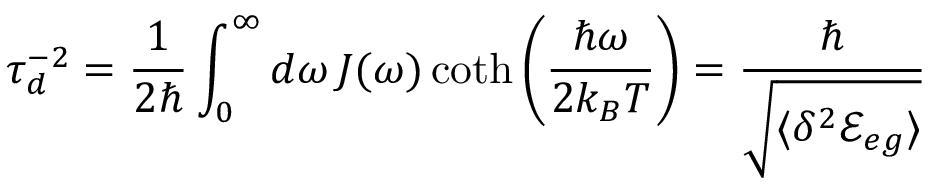<formula> <loc_0><loc_0><loc_500><loc_500>\tau _ { d } ^ { - 2 } = \frac { 1 } { 2 } \int _ { 0 } ^ { \infty } d \omega \, J ( \omega ) \coth \left ( \frac { \hbar { \omega } } { 2 k _ { B } T } \right ) = \frac { } { \sqrt { \langle \delta ^ { 2 } { \mathcal { E } } _ { e g } \rangle } }</formula> 